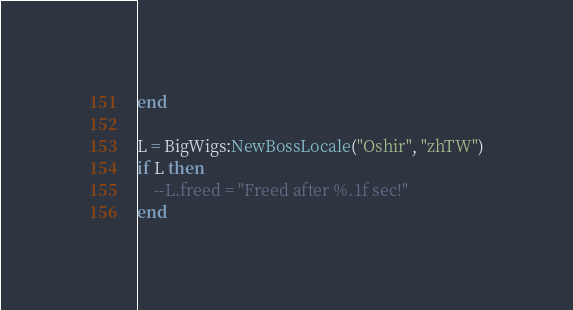<code> <loc_0><loc_0><loc_500><loc_500><_Lua_>end

L = BigWigs:NewBossLocale("Oshir", "zhTW")
if L then
	--L.freed = "Freed after %.1f sec!"
end
</code> 